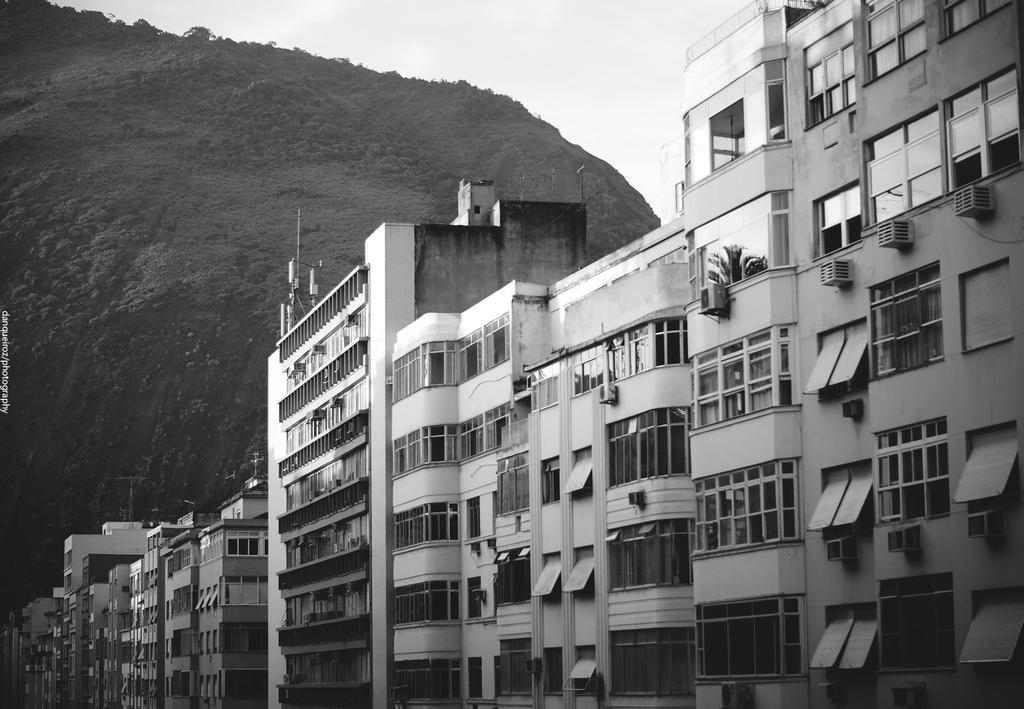What is the color scheme of the image? The image is black and white. What type of structures can be seen in the image? There are buildings in the image. How are the buildings positioned in relation to each other? The buildings are beside each other. What can be seen in the background of the image? There is a hill in the background of the image. What is visible at the top of the image? The sky is visible at the top of the image. What type of yam is being grown on the hill in the image? There is no yam present in the image; it features buildings and a hill in a black and white color scheme. What authority is responsible for maintaining the buildings in the image? The image does not provide information about the authority responsible for maintaining the buildings. 